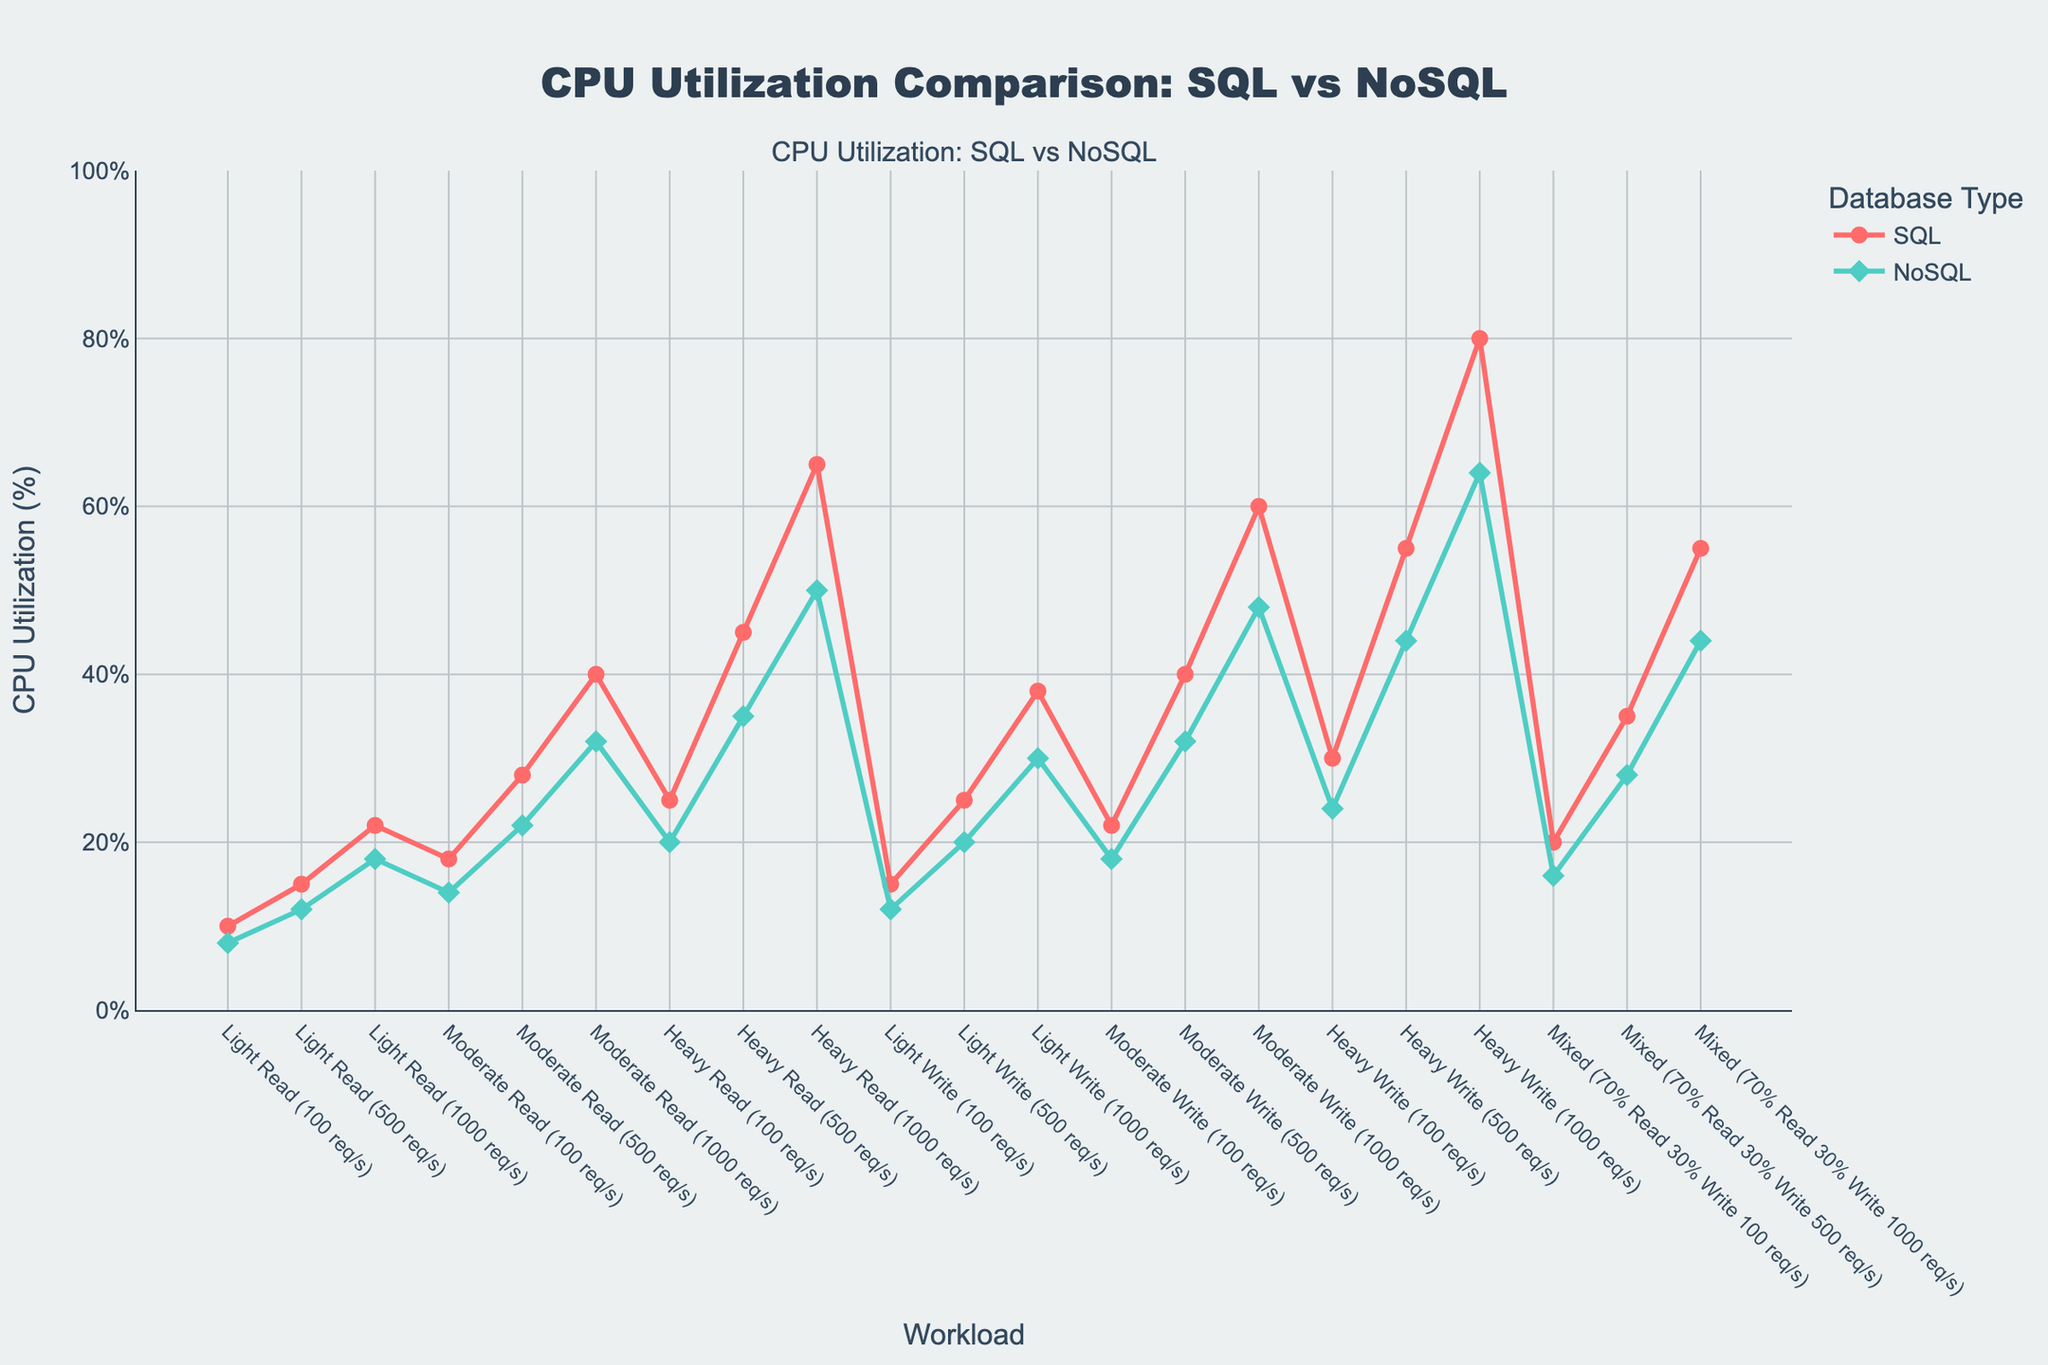Which database type has lower CPU utilization for light read workloads? Observe the lines representing SQL and NoSQL CPU utilization for light read workloads (100 req/s, 500 req/s, 1000 req/s). NoSQL frequently exhibits lower CPU utilization than SQL.
Answer: NoSQL For a mixed workload with 1000 req/s, which database has higher CPU utilization? Look at the CPU utilization values for mixed (70% Read 30% Write 1000 req/s) on the plot. SQL exhibits a higher value (55%) compared to NoSQL (44%).
Answer: SQL By how much does CPU utilization increase for SQL from a moderate write workload of 100 req/s to 1000 req/s? Identify the CPU utilization values for SQL at moderate write workloads of 100 req/s (22%) and 1000 req/s (60%). Calculate the difference: 60% - 22%.
Answer: 38% What is the CPU utilization difference between SQL and NoSQL databases under a heavy write workload of 500 req/s? Find the CPU utilization values for SQL and NoSQL under heavy write workloads with 500 req/s. The difference is 55% for SQL and 44% for NoSQL: 55% - 44%.
Answer: 11% Which type of workload shows the greatest difference in CPU utilization between SQL and NoSQL at 1000 req/s? Review the CPU utilization differences for each workload at 1000 req/s. The greatest difference is seen in the Heavy Write workload: SQL at 80%, NoSQL at 64%, resulting in a 16% difference.
Answer: Heavy Write What is the visual difference in marker type between SQL and NoSQL lines? Inspect the plot markers for each series. SQL uses circular markers, whereas NoSQL uses diamond markers.
Answer: SQL: Circle, NoSQL: Diamond Is CPU utilization higher for SQL or NoSQL in light read workloads with 1000 req/s? Compare the lines for light read workloads at 1000 req/s. SQL has higher utilization at 22% compared to 18% for NoSQL.
Answer: SQL How does CPU utilization change for NoSQL from light to heavy read workloads at 500 req/s? Check the NoSQL values for light read (500 req/s = 12%) and heavy read (500 req/s = 35%). The increase is 35% - 12%.
Answer: 23% Which has a higher CPU utilization at moderate read workloads of 500 req/s, SQL or NoSQL? Examine CPU utilization for SQL and NoSQL at moderate read workloads (500 req/s). SQL is at 28%, while NoSQL is at 22%.
Answer: SQL For the heaviest workload (1000 req/s), what is the average CPU utilization across all workload types for NoSQL? Calculate the average of CPU utilization values for all workload types (read, write, mixed) at 1000 req/s for NoSQL: (18 + 32 + 50 + 30 + 48 + 64 + 44) / 7 = 286 / 7.
Answer: 40.9% 